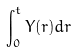<formula> <loc_0><loc_0><loc_500><loc_500>\int _ { 0 } ^ { t } Y ( r ) d r</formula> 